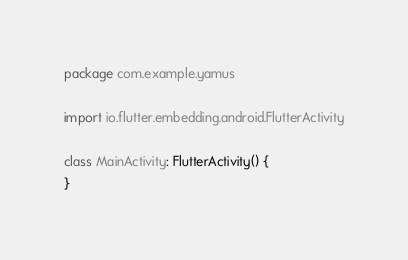<code> <loc_0><loc_0><loc_500><loc_500><_Kotlin_>package com.example.yamus

import io.flutter.embedding.android.FlutterActivity

class MainActivity: FlutterActivity() {
}
</code> 